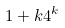<formula> <loc_0><loc_0><loc_500><loc_500>1 + k 4 ^ { k }</formula> 